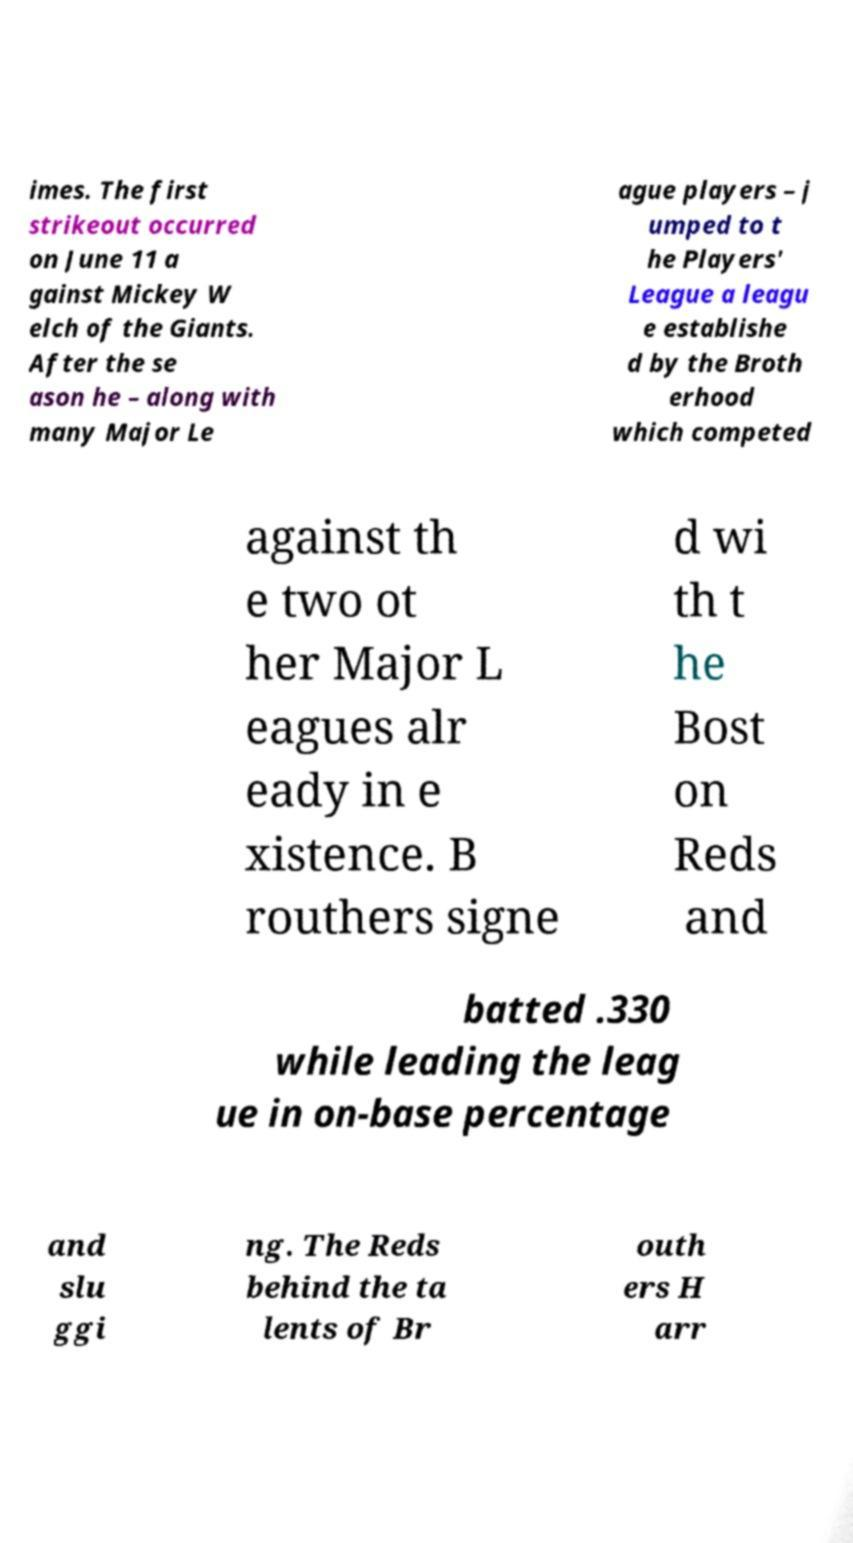Can you accurately transcribe the text from the provided image for me? imes. The first strikeout occurred on June 11 a gainst Mickey W elch of the Giants. After the se ason he – along with many Major Le ague players – j umped to t he Players' League a leagu e establishe d by the Broth erhood which competed against th e two ot her Major L eagues alr eady in e xistence. B routhers signe d wi th t he Bost on Reds and batted .330 while leading the leag ue in on-base percentage and slu ggi ng. The Reds behind the ta lents of Br outh ers H arr 